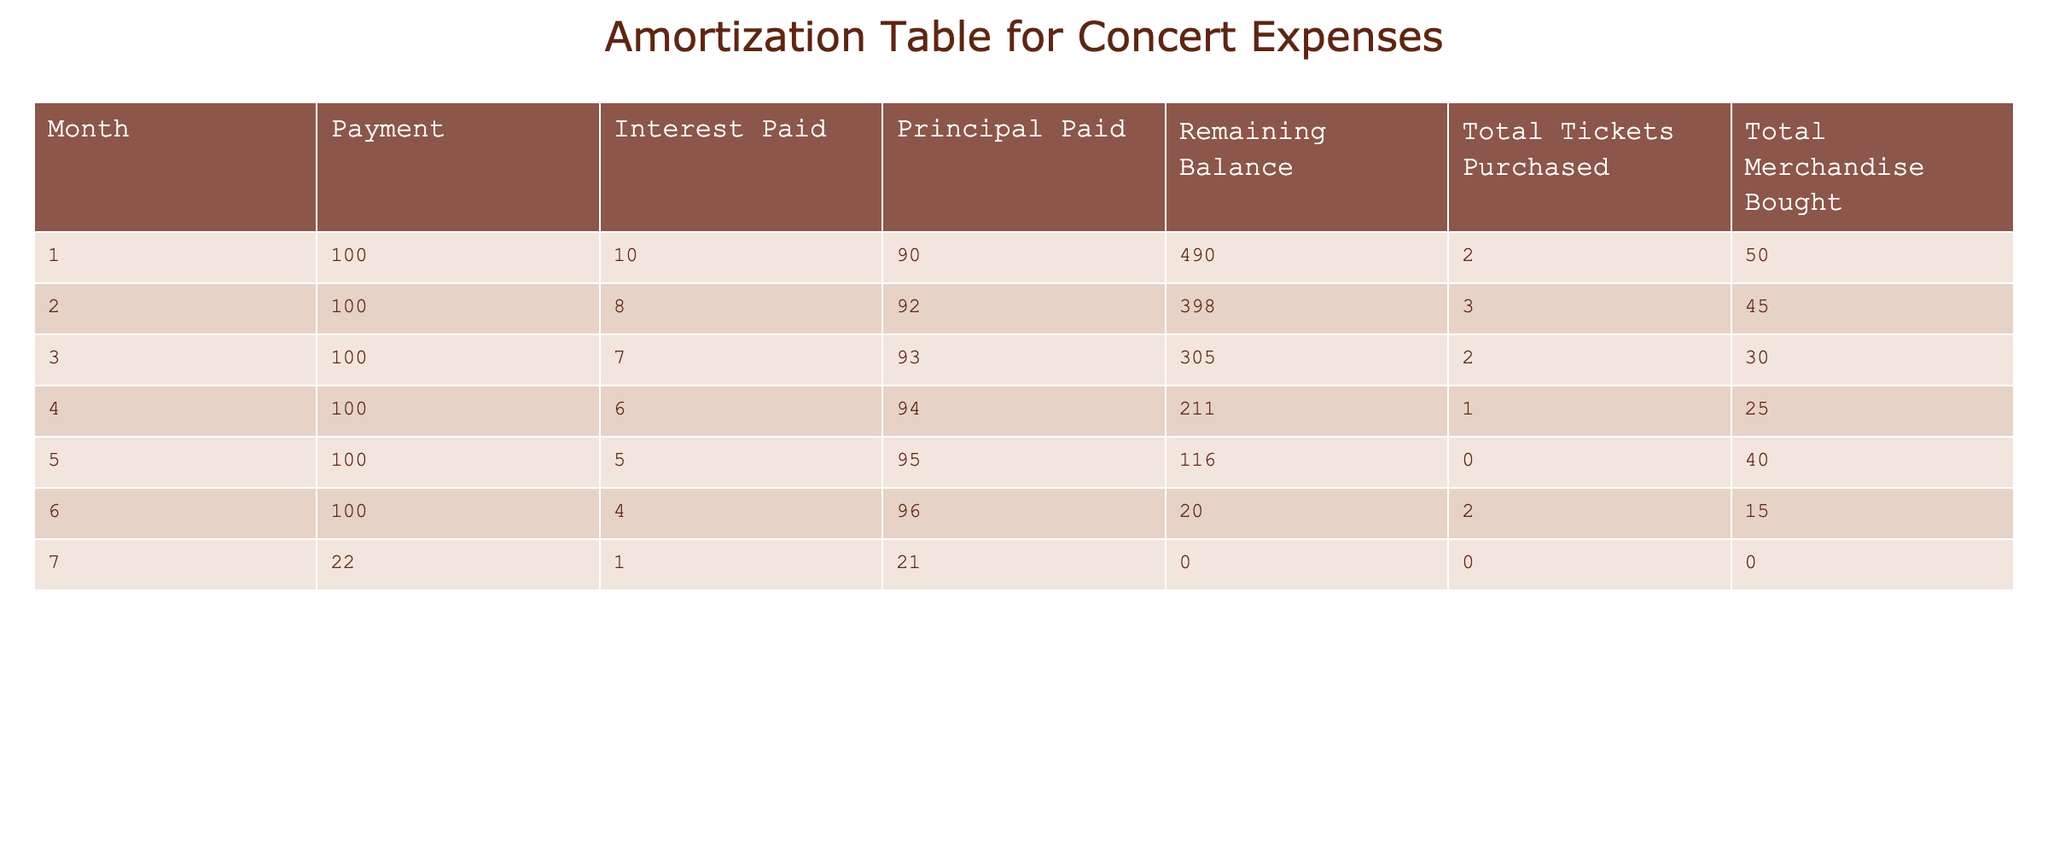What was the remaining balance after month 3? In the table, by looking at the "Remaining Balance" column, the value for month 3 is 305.
Answer: 305 How much total principal was paid over the 7 months? To find the total principal paid, we sum the "Principal Paid" values for all months: 90 + 92 + 93 + 94 + 95 + 96 + 21 = 581.
Answer: 581 What was the highest amount spent on merchandise in a single month? By reviewing the "Total Merchandise Bought" column, the highest value is 50 from month 1.
Answer: 50 Was the total amount paid in the last month greater than in the previous months? In month 7, the total payment was 22. The previous months all show payments of 100. Thus, this is less than previous payments.
Answer: No What is the average interest paid per month over the 7 months? The sum of the "Interest Paid" column is 10 + 8 + 7 + 6 + 5 + 4 + 1 = 41. Dividing by 7 gives an average interest paid of 41 / 7 = 5.857, which rounds to about 5.86.
Answer: 5.86 Did the total tickets purchased ever decrease from one month to the next? Looking at the "Total Tickets Purchased" column, the values are 2, 3, 2, 1, 0, 2, 0. There is a decrease from month 3 to month 4, from 2 to 1.
Answer: Yes What percentage of the total payments was allocated to interest payments? The total payments over 7 months are 100 + 100 + 100 + 100 + 100 + 100 + 22 = 622. The total interest paid is 41. The percentage is (41 / 622) * 100 = 6.59%.
Answer: 6.59% How much merchandise was purchased in the month with the least total tickets purchased? The month with the least total tickets purchased is month 5 (0 tickets), and the corresponding "Total Merchandise Bought" is 40.
Answer: 40 